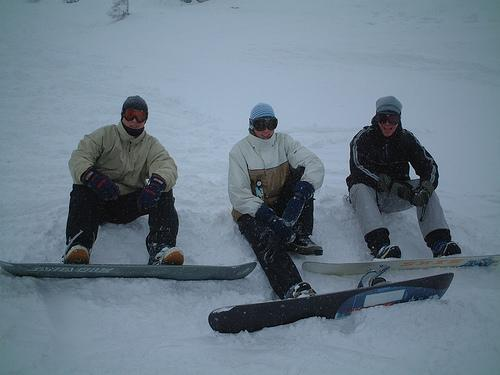Sitting like this allows the snowboarders to avoid doing what with their Snow boards?

Choices:
A) losing them
B) selling them
C) scratching them
D) removing them removing them 